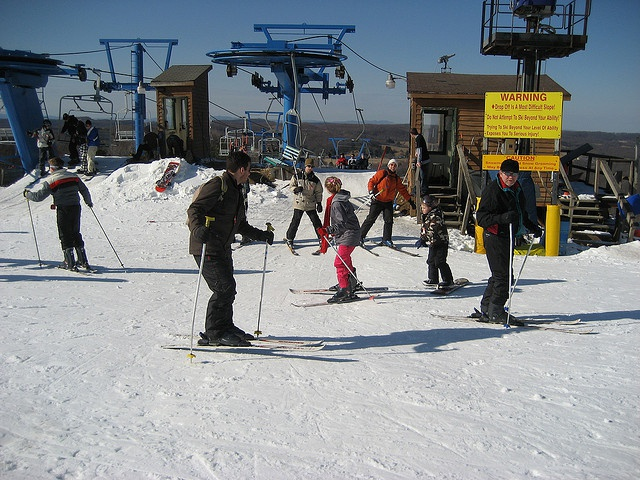Describe the objects in this image and their specific colors. I can see people in blue, black, gray, and lightgray tones, people in blue, black, gray, and maroon tones, people in blue, black, gray, lightgray, and navy tones, people in blue, black, gray, maroon, and brown tones, and people in blue, black, gray, and darkgray tones in this image. 